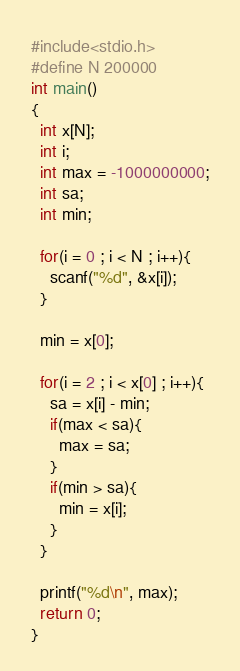<code> <loc_0><loc_0><loc_500><loc_500><_C_>#include<stdio.h>
#define N 200000
int main()
{
  int x[N];
  int i;
  int max = -1000000000;
  int sa;
  int min;

  for(i = 0 ; i < N ; i++){
    scanf("%d", &x[i]);
  }

  min = x[0];

  for(i = 2 ; i < x[0] ; i++){
    sa = x[i] - min;
    if(max < sa){
      max = sa;
    }
    if(min > sa){
      min = x[i];
    }
  }

  printf("%d\n", max);
  return 0;
}</code> 